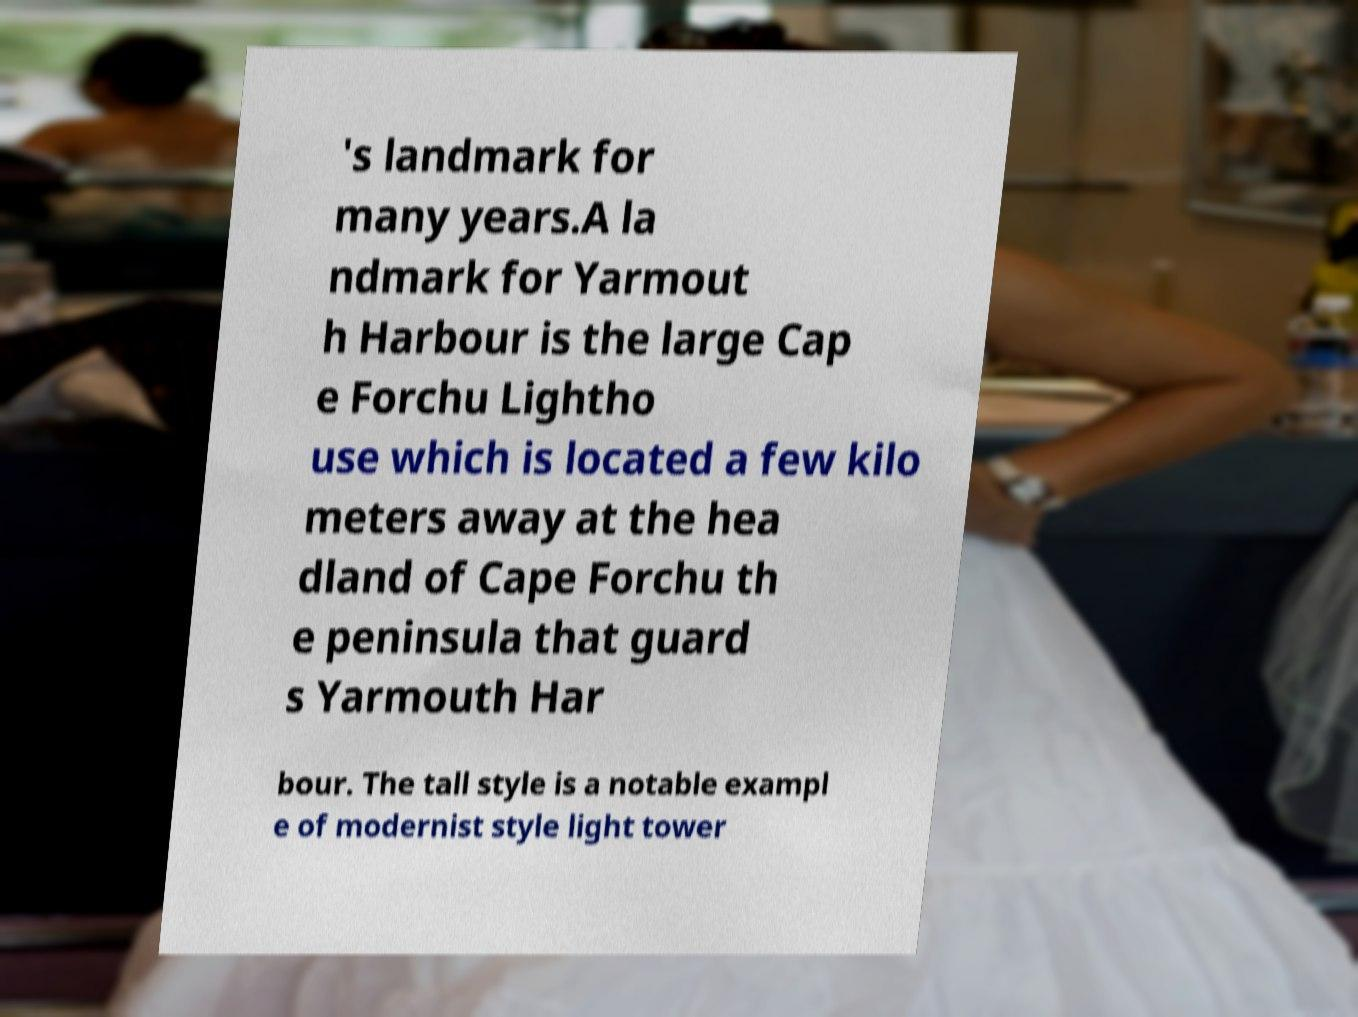Can you read and provide the text displayed in the image?This photo seems to have some interesting text. Can you extract and type it out for me? 's landmark for many years.A la ndmark for Yarmout h Harbour is the large Cap e Forchu Lightho use which is located a few kilo meters away at the hea dland of Cape Forchu th e peninsula that guard s Yarmouth Har bour. The tall style is a notable exampl e of modernist style light tower 